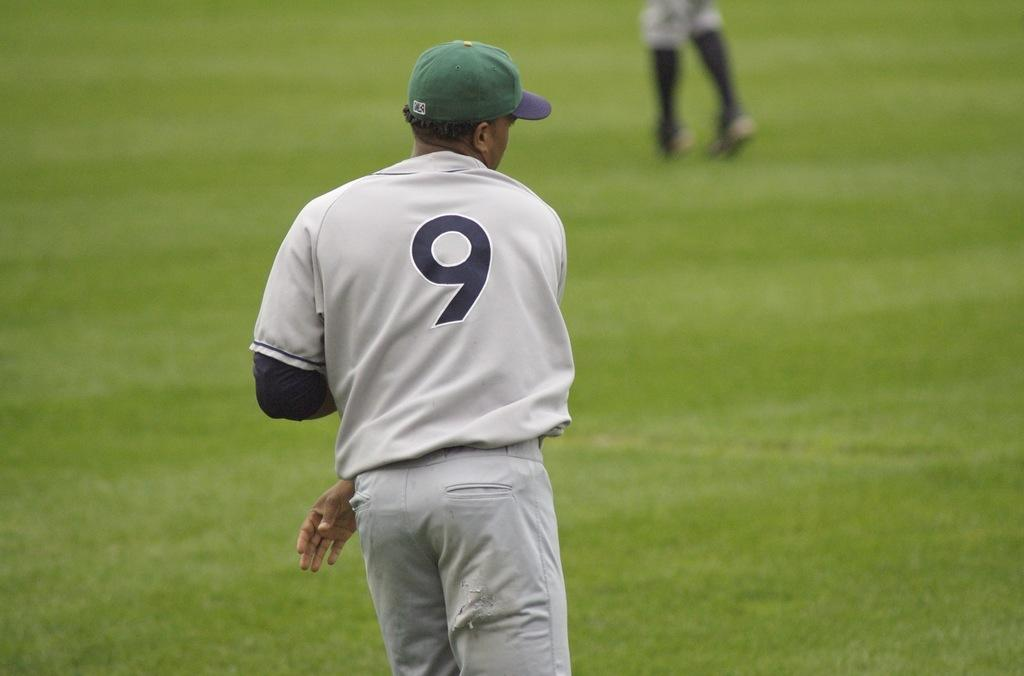What is there is a man standing in the center of the image, what is he wearing on his head? The man is wearing a hat. What can be seen in the background of the image? Grass is present in the background of the image. Can you describe any other people in the image? A person's legs are visible at the top of the image. What type of goldfish can be seen swimming in the image? There are no goldfish present in the image; it features a man standing in the center and grass in the background. What type of food is the man eating in the image? There is no food visible in the image; the man is simply standing and wearing a hat. 